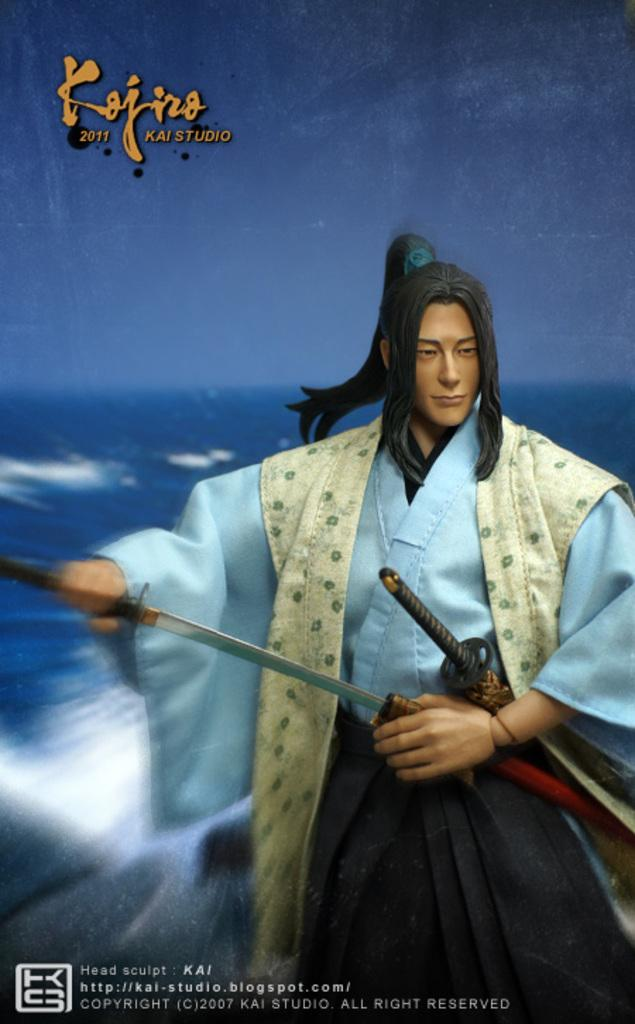What is featured in the image? There is a poster in the image. What can be found on the poster? There is text on the poster. What activity is the person in the image engaged in? There is a person holding swords in the image. What type of pleasure can be seen on the turkey's face in the image? There is no turkey present in the image, so it is not possible to determine any pleasure on its face. 